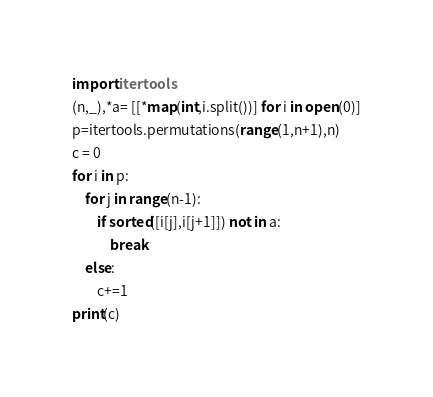Convert code to text. <code><loc_0><loc_0><loc_500><loc_500><_Python_>import itertools
(n,_),*a= [[*map(int,i.split())] for i in open(0)]
p=itertools.permutations(range(1,n+1),n)
c = 0
for i in p:
    for j in range(n-1):
        if sorted([i[j],i[j+1]]) not in a:
            break
    else:
        c+=1
print(c)</code> 